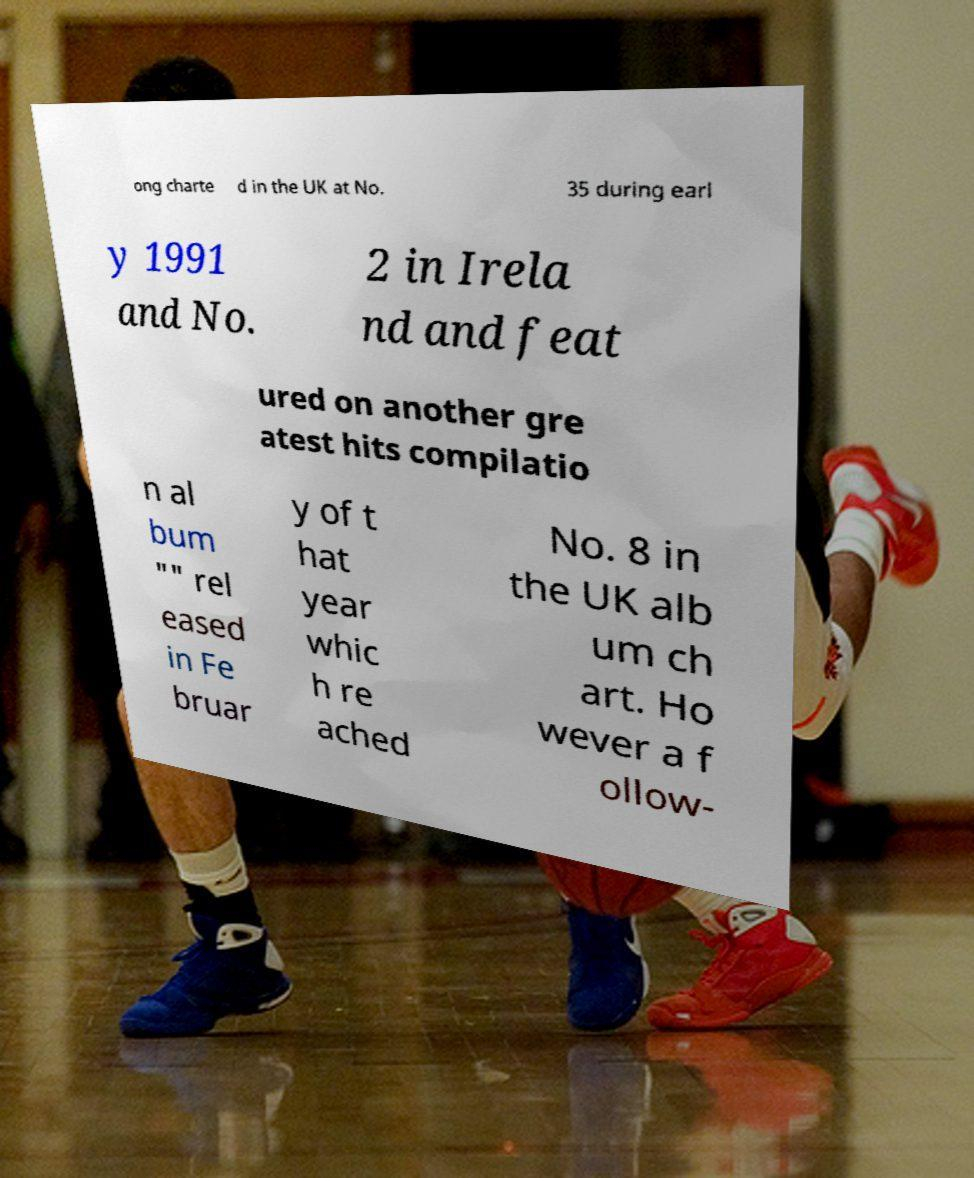For documentation purposes, I need the text within this image transcribed. Could you provide that? ong charte d in the UK at No. 35 during earl y 1991 and No. 2 in Irela nd and feat ured on another gre atest hits compilatio n al bum "" rel eased in Fe bruar y of t hat year whic h re ached No. 8 in the UK alb um ch art. Ho wever a f ollow- 